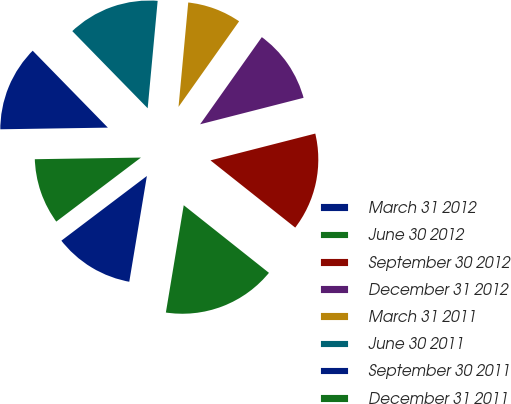Convert chart. <chart><loc_0><loc_0><loc_500><loc_500><pie_chart><fcel>March 31 2012<fcel>June 30 2012<fcel>September 30 2012<fcel>December 31 2012<fcel>March 31 2011<fcel>June 30 2011<fcel>September 30 2011<fcel>December 31 2011<nl><fcel>12.07%<fcel>16.95%<fcel>14.66%<fcel>11.21%<fcel>8.33%<fcel>13.79%<fcel>12.93%<fcel>10.06%<nl></chart> 